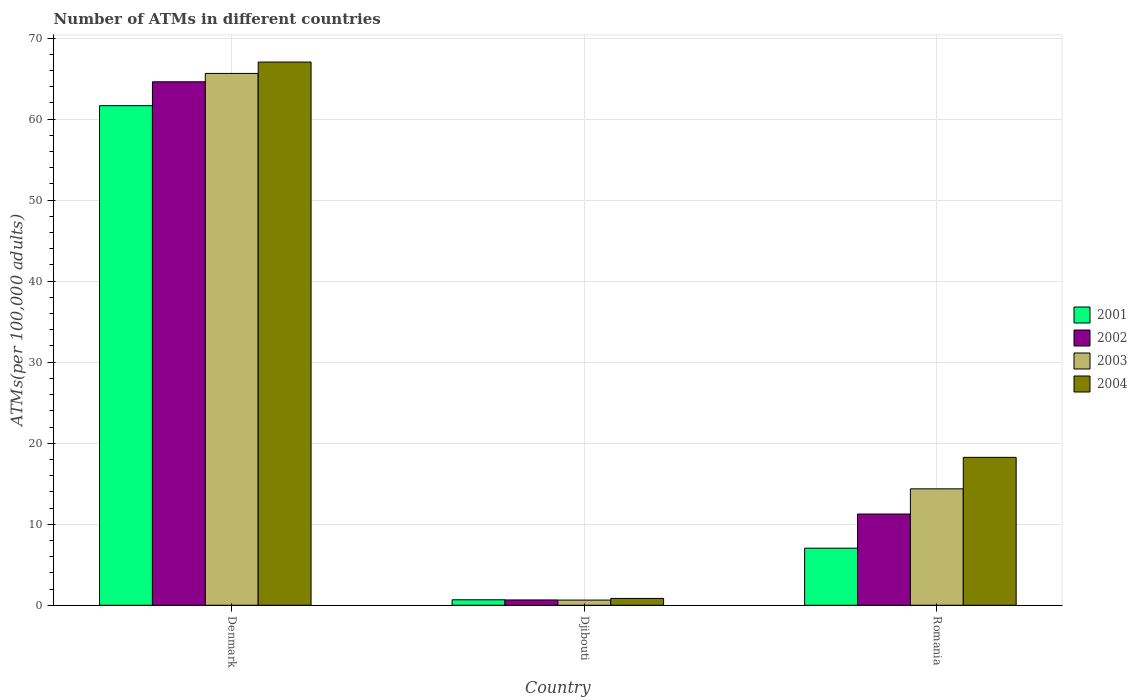How many different coloured bars are there?
Provide a succinct answer. 4. How many groups of bars are there?
Give a very brief answer. 3. Are the number of bars per tick equal to the number of legend labels?
Provide a succinct answer. Yes. Are the number of bars on each tick of the X-axis equal?
Provide a short and direct response. Yes. How many bars are there on the 2nd tick from the left?
Offer a terse response. 4. What is the number of ATMs in 2002 in Djibouti?
Provide a short and direct response. 0.66. Across all countries, what is the maximum number of ATMs in 2003?
Make the answer very short. 65.64. Across all countries, what is the minimum number of ATMs in 2003?
Provide a short and direct response. 0.64. In which country was the number of ATMs in 2004 minimum?
Your answer should be very brief. Djibouti. What is the total number of ATMs in 2004 in the graph?
Your answer should be compact. 86.14. What is the difference between the number of ATMs in 2003 in Denmark and that in Djibouti?
Offer a terse response. 65. What is the difference between the number of ATMs in 2004 in Denmark and the number of ATMs in 2003 in Romania?
Keep it short and to the point. 52.67. What is the average number of ATMs in 2004 per country?
Ensure brevity in your answer.  28.71. What is the difference between the number of ATMs of/in 2004 and number of ATMs of/in 2003 in Djibouti?
Make the answer very short. 0.21. What is the ratio of the number of ATMs in 2001 in Denmark to that in Romania?
Your response must be concise. 8.75. Is the number of ATMs in 2003 in Denmark less than that in Djibouti?
Make the answer very short. No. Is the difference between the number of ATMs in 2004 in Denmark and Djibouti greater than the difference between the number of ATMs in 2003 in Denmark and Djibouti?
Keep it short and to the point. Yes. What is the difference between the highest and the second highest number of ATMs in 2003?
Your answer should be compact. -65. What is the difference between the highest and the lowest number of ATMs in 2004?
Your response must be concise. 66.2. In how many countries, is the number of ATMs in 2002 greater than the average number of ATMs in 2002 taken over all countries?
Offer a very short reply. 1. Is the sum of the number of ATMs in 2002 in Denmark and Djibouti greater than the maximum number of ATMs in 2004 across all countries?
Make the answer very short. No. Is it the case that in every country, the sum of the number of ATMs in 2004 and number of ATMs in 2002 is greater than the sum of number of ATMs in 2001 and number of ATMs in 2003?
Provide a succinct answer. No. What does the 1st bar from the right in Djibouti represents?
Give a very brief answer. 2004. How many countries are there in the graph?
Make the answer very short. 3. What is the difference between two consecutive major ticks on the Y-axis?
Offer a very short reply. 10. Does the graph contain any zero values?
Provide a succinct answer. No. Does the graph contain grids?
Offer a very short reply. Yes. Where does the legend appear in the graph?
Your answer should be very brief. Center right. How are the legend labels stacked?
Your answer should be very brief. Vertical. What is the title of the graph?
Ensure brevity in your answer.  Number of ATMs in different countries. Does "1970" appear as one of the legend labels in the graph?
Your answer should be compact. No. What is the label or title of the Y-axis?
Your answer should be compact. ATMs(per 100,0 adults). What is the ATMs(per 100,000 adults) of 2001 in Denmark?
Your answer should be compact. 61.66. What is the ATMs(per 100,000 adults) in 2002 in Denmark?
Provide a short and direct response. 64.61. What is the ATMs(per 100,000 adults) in 2003 in Denmark?
Keep it short and to the point. 65.64. What is the ATMs(per 100,000 adults) of 2004 in Denmark?
Provide a succinct answer. 67.04. What is the ATMs(per 100,000 adults) of 2001 in Djibouti?
Your response must be concise. 0.68. What is the ATMs(per 100,000 adults) of 2002 in Djibouti?
Offer a very short reply. 0.66. What is the ATMs(per 100,000 adults) in 2003 in Djibouti?
Your answer should be compact. 0.64. What is the ATMs(per 100,000 adults) of 2004 in Djibouti?
Make the answer very short. 0.84. What is the ATMs(per 100,000 adults) in 2001 in Romania?
Offer a terse response. 7.04. What is the ATMs(per 100,000 adults) of 2002 in Romania?
Your answer should be very brief. 11.26. What is the ATMs(per 100,000 adults) in 2003 in Romania?
Ensure brevity in your answer.  14.37. What is the ATMs(per 100,000 adults) of 2004 in Romania?
Offer a terse response. 18.26. Across all countries, what is the maximum ATMs(per 100,000 adults) in 2001?
Give a very brief answer. 61.66. Across all countries, what is the maximum ATMs(per 100,000 adults) in 2002?
Offer a terse response. 64.61. Across all countries, what is the maximum ATMs(per 100,000 adults) of 2003?
Make the answer very short. 65.64. Across all countries, what is the maximum ATMs(per 100,000 adults) in 2004?
Make the answer very short. 67.04. Across all countries, what is the minimum ATMs(per 100,000 adults) in 2001?
Provide a succinct answer. 0.68. Across all countries, what is the minimum ATMs(per 100,000 adults) in 2002?
Your answer should be compact. 0.66. Across all countries, what is the minimum ATMs(per 100,000 adults) of 2003?
Ensure brevity in your answer.  0.64. Across all countries, what is the minimum ATMs(per 100,000 adults) in 2004?
Your response must be concise. 0.84. What is the total ATMs(per 100,000 adults) in 2001 in the graph?
Provide a short and direct response. 69.38. What is the total ATMs(per 100,000 adults) of 2002 in the graph?
Ensure brevity in your answer.  76.52. What is the total ATMs(per 100,000 adults) of 2003 in the graph?
Provide a succinct answer. 80.65. What is the total ATMs(per 100,000 adults) in 2004 in the graph?
Offer a very short reply. 86.14. What is the difference between the ATMs(per 100,000 adults) of 2001 in Denmark and that in Djibouti?
Your answer should be compact. 60.98. What is the difference between the ATMs(per 100,000 adults) of 2002 in Denmark and that in Djibouti?
Your answer should be very brief. 63.95. What is the difference between the ATMs(per 100,000 adults) of 2003 in Denmark and that in Djibouti?
Keep it short and to the point. 65. What is the difference between the ATMs(per 100,000 adults) of 2004 in Denmark and that in Djibouti?
Your answer should be very brief. 66.2. What is the difference between the ATMs(per 100,000 adults) in 2001 in Denmark and that in Romania?
Your answer should be compact. 54.61. What is the difference between the ATMs(per 100,000 adults) in 2002 in Denmark and that in Romania?
Your answer should be very brief. 53.35. What is the difference between the ATMs(per 100,000 adults) of 2003 in Denmark and that in Romania?
Ensure brevity in your answer.  51.27. What is the difference between the ATMs(per 100,000 adults) in 2004 in Denmark and that in Romania?
Keep it short and to the point. 48.79. What is the difference between the ATMs(per 100,000 adults) in 2001 in Djibouti and that in Romania?
Give a very brief answer. -6.37. What is the difference between the ATMs(per 100,000 adults) in 2002 in Djibouti and that in Romania?
Make the answer very short. -10.6. What is the difference between the ATMs(per 100,000 adults) of 2003 in Djibouti and that in Romania?
Offer a very short reply. -13.73. What is the difference between the ATMs(per 100,000 adults) of 2004 in Djibouti and that in Romania?
Give a very brief answer. -17.41. What is the difference between the ATMs(per 100,000 adults) of 2001 in Denmark and the ATMs(per 100,000 adults) of 2002 in Djibouti?
Provide a short and direct response. 61. What is the difference between the ATMs(per 100,000 adults) in 2001 in Denmark and the ATMs(per 100,000 adults) in 2003 in Djibouti?
Make the answer very short. 61.02. What is the difference between the ATMs(per 100,000 adults) in 2001 in Denmark and the ATMs(per 100,000 adults) in 2004 in Djibouti?
Ensure brevity in your answer.  60.81. What is the difference between the ATMs(per 100,000 adults) of 2002 in Denmark and the ATMs(per 100,000 adults) of 2003 in Djibouti?
Your answer should be compact. 63.97. What is the difference between the ATMs(per 100,000 adults) in 2002 in Denmark and the ATMs(per 100,000 adults) in 2004 in Djibouti?
Provide a short and direct response. 63.76. What is the difference between the ATMs(per 100,000 adults) of 2003 in Denmark and the ATMs(per 100,000 adults) of 2004 in Djibouti?
Keep it short and to the point. 64.79. What is the difference between the ATMs(per 100,000 adults) of 2001 in Denmark and the ATMs(per 100,000 adults) of 2002 in Romania?
Offer a terse response. 50.4. What is the difference between the ATMs(per 100,000 adults) in 2001 in Denmark and the ATMs(per 100,000 adults) in 2003 in Romania?
Give a very brief answer. 47.29. What is the difference between the ATMs(per 100,000 adults) in 2001 in Denmark and the ATMs(per 100,000 adults) in 2004 in Romania?
Provide a short and direct response. 43.4. What is the difference between the ATMs(per 100,000 adults) in 2002 in Denmark and the ATMs(per 100,000 adults) in 2003 in Romania?
Provide a succinct answer. 50.24. What is the difference between the ATMs(per 100,000 adults) of 2002 in Denmark and the ATMs(per 100,000 adults) of 2004 in Romania?
Ensure brevity in your answer.  46.35. What is the difference between the ATMs(per 100,000 adults) in 2003 in Denmark and the ATMs(per 100,000 adults) in 2004 in Romania?
Provide a succinct answer. 47.38. What is the difference between the ATMs(per 100,000 adults) of 2001 in Djibouti and the ATMs(per 100,000 adults) of 2002 in Romania?
Keep it short and to the point. -10.58. What is the difference between the ATMs(per 100,000 adults) of 2001 in Djibouti and the ATMs(per 100,000 adults) of 2003 in Romania?
Offer a terse response. -13.69. What is the difference between the ATMs(per 100,000 adults) in 2001 in Djibouti and the ATMs(per 100,000 adults) in 2004 in Romania?
Provide a short and direct response. -17.58. What is the difference between the ATMs(per 100,000 adults) in 2002 in Djibouti and the ATMs(per 100,000 adults) in 2003 in Romania?
Give a very brief answer. -13.71. What is the difference between the ATMs(per 100,000 adults) in 2002 in Djibouti and the ATMs(per 100,000 adults) in 2004 in Romania?
Your answer should be compact. -17.6. What is the difference between the ATMs(per 100,000 adults) in 2003 in Djibouti and the ATMs(per 100,000 adults) in 2004 in Romania?
Ensure brevity in your answer.  -17.62. What is the average ATMs(per 100,000 adults) of 2001 per country?
Ensure brevity in your answer.  23.13. What is the average ATMs(per 100,000 adults) in 2002 per country?
Your answer should be very brief. 25.51. What is the average ATMs(per 100,000 adults) of 2003 per country?
Ensure brevity in your answer.  26.88. What is the average ATMs(per 100,000 adults) in 2004 per country?
Your answer should be compact. 28.71. What is the difference between the ATMs(per 100,000 adults) in 2001 and ATMs(per 100,000 adults) in 2002 in Denmark?
Your answer should be very brief. -2.95. What is the difference between the ATMs(per 100,000 adults) of 2001 and ATMs(per 100,000 adults) of 2003 in Denmark?
Ensure brevity in your answer.  -3.98. What is the difference between the ATMs(per 100,000 adults) of 2001 and ATMs(per 100,000 adults) of 2004 in Denmark?
Give a very brief answer. -5.39. What is the difference between the ATMs(per 100,000 adults) in 2002 and ATMs(per 100,000 adults) in 2003 in Denmark?
Offer a very short reply. -1.03. What is the difference between the ATMs(per 100,000 adults) of 2002 and ATMs(per 100,000 adults) of 2004 in Denmark?
Your response must be concise. -2.44. What is the difference between the ATMs(per 100,000 adults) of 2003 and ATMs(per 100,000 adults) of 2004 in Denmark?
Keep it short and to the point. -1.41. What is the difference between the ATMs(per 100,000 adults) of 2001 and ATMs(per 100,000 adults) of 2002 in Djibouti?
Give a very brief answer. 0.02. What is the difference between the ATMs(per 100,000 adults) of 2001 and ATMs(per 100,000 adults) of 2003 in Djibouti?
Your response must be concise. 0.04. What is the difference between the ATMs(per 100,000 adults) of 2001 and ATMs(per 100,000 adults) of 2004 in Djibouti?
Offer a very short reply. -0.17. What is the difference between the ATMs(per 100,000 adults) in 2002 and ATMs(per 100,000 adults) in 2003 in Djibouti?
Offer a very short reply. 0.02. What is the difference between the ATMs(per 100,000 adults) in 2002 and ATMs(per 100,000 adults) in 2004 in Djibouti?
Your answer should be very brief. -0.19. What is the difference between the ATMs(per 100,000 adults) of 2003 and ATMs(per 100,000 adults) of 2004 in Djibouti?
Give a very brief answer. -0.21. What is the difference between the ATMs(per 100,000 adults) in 2001 and ATMs(per 100,000 adults) in 2002 in Romania?
Offer a very short reply. -4.21. What is the difference between the ATMs(per 100,000 adults) in 2001 and ATMs(per 100,000 adults) in 2003 in Romania?
Your answer should be compact. -7.32. What is the difference between the ATMs(per 100,000 adults) of 2001 and ATMs(per 100,000 adults) of 2004 in Romania?
Offer a very short reply. -11.21. What is the difference between the ATMs(per 100,000 adults) in 2002 and ATMs(per 100,000 adults) in 2003 in Romania?
Provide a succinct answer. -3.11. What is the difference between the ATMs(per 100,000 adults) of 2002 and ATMs(per 100,000 adults) of 2004 in Romania?
Your answer should be compact. -7. What is the difference between the ATMs(per 100,000 adults) in 2003 and ATMs(per 100,000 adults) in 2004 in Romania?
Offer a terse response. -3.89. What is the ratio of the ATMs(per 100,000 adults) of 2001 in Denmark to that in Djibouti?
Your answer should be compact. 91.18. What is the ratio of the ATMs(per 100,000 adults) of 2002 in Denmark to that in Djibouti?
Offer a very short reply. 98.45. What is the ratio of the ATMs(per 100,000 adults) in 2003 in Denmark to that in Djibouti?
Provide a short and direct response. 102.88. What is the ratio of the ATMs(per 100,000 adults) of 2004 in Denmark to that in Djibouti?
Ensure brevity in your answer.  79.46. What is the ratio of the ATMs(per 100,000 adults) of 2001 in Denmark to that in Romania?
Ensure brevity in your answer.  8.75. What is the ratio of the ATMs(per 100,000 adults) in 2002 in Denmark to that in Romania?
Provide a succinct answer. 5.74. What is the ratio of the ATMs(per 100,000 adults) in 2003 in Denmark to that in Romania?
Provide a succinct answer. 4.57. What is the ratio of the ATMs(per 100,000 adults) in 2004 in Denmark to that in Romania?
Keep it short and to the point. 3.67. What is the ratio of the ATMs(per 100,000 adults) of 2001 in Djibouti to that in Romania?
Offer a very short reply. 0.1. What is the ratio of the ATMs(per 100,000 adults) in 2002 in Djibouti to that in Romania?
Your response must be concise. 0.06. What is the ratio of the ATMs(per 100,000 adults) in 2003 in Djibouti to that in Romania?
Your answer should be very brief. 0.04. What is the ratio of the ATMs(per 100,000 adults) in 2004 in Djibouti to that in Romania?
Offer a very short reply. 0.05. What is the difference between the highest and the second highest ATMs(per 100,000 adults) of 2001?
Ensure brevity in your answer.  54.61. What is the difference between the highest and the second highest ATMs(per 100,000 adults) of 2002?
Offer a terse response. 53.35. What is the difference between the highest and the second highest ATMs(per 100,000 adults) in 2003?
Offer a very short reply. 51.27. What is the difference between the highest and the second highest ATMs(per 100,000 adults) in 2004?
Your answer should be compact. 48.79. What is the difference between the highest and the lowest ATMs(per 100,000 adults) in 2001?
Your response must be concise. 60.98. What is the difference between the highest and the lowest ATMs(per 100,000 adults) of 2002?
Ensure brevity in your answer.  63.95. What is the difference between the highest and the lowest ATMs(per 100,000 adults) in 2003?
Your answer should be compact. 65. What is the difference between the highest and the lowest ATMs(per 100,000 adults) of 2004?
Give a very brief answer. 66.2. 